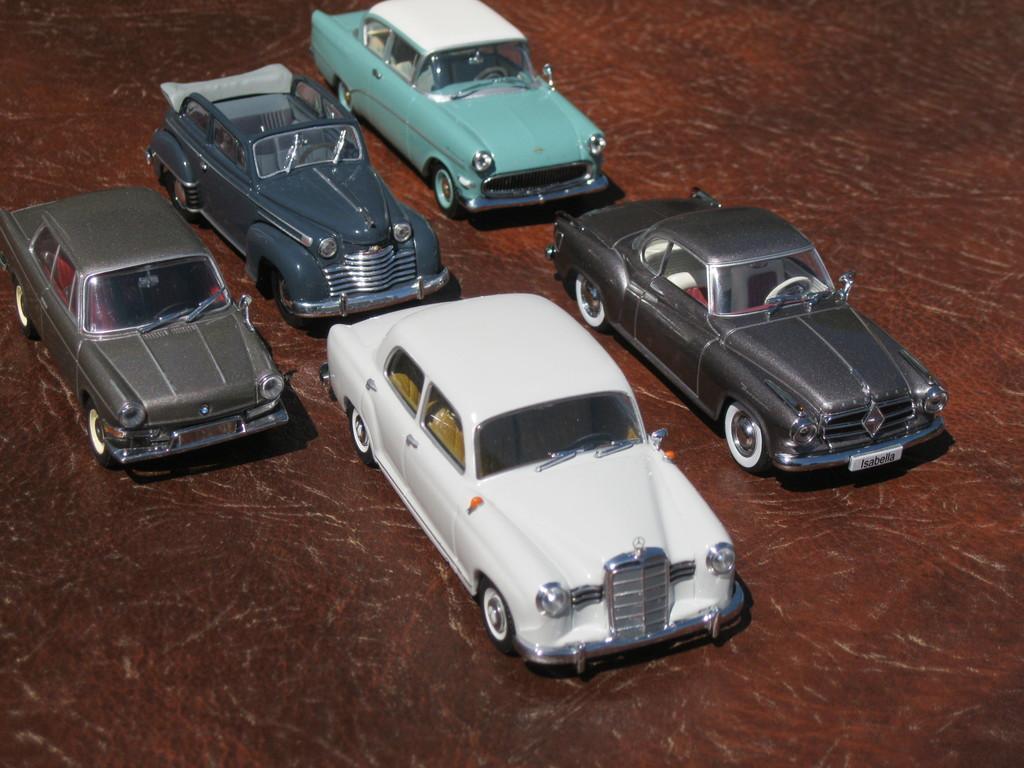Could you give a brief overview of what you see in this image? In this image I can see few vehicles and the vehicles are in white, gray and green color. 